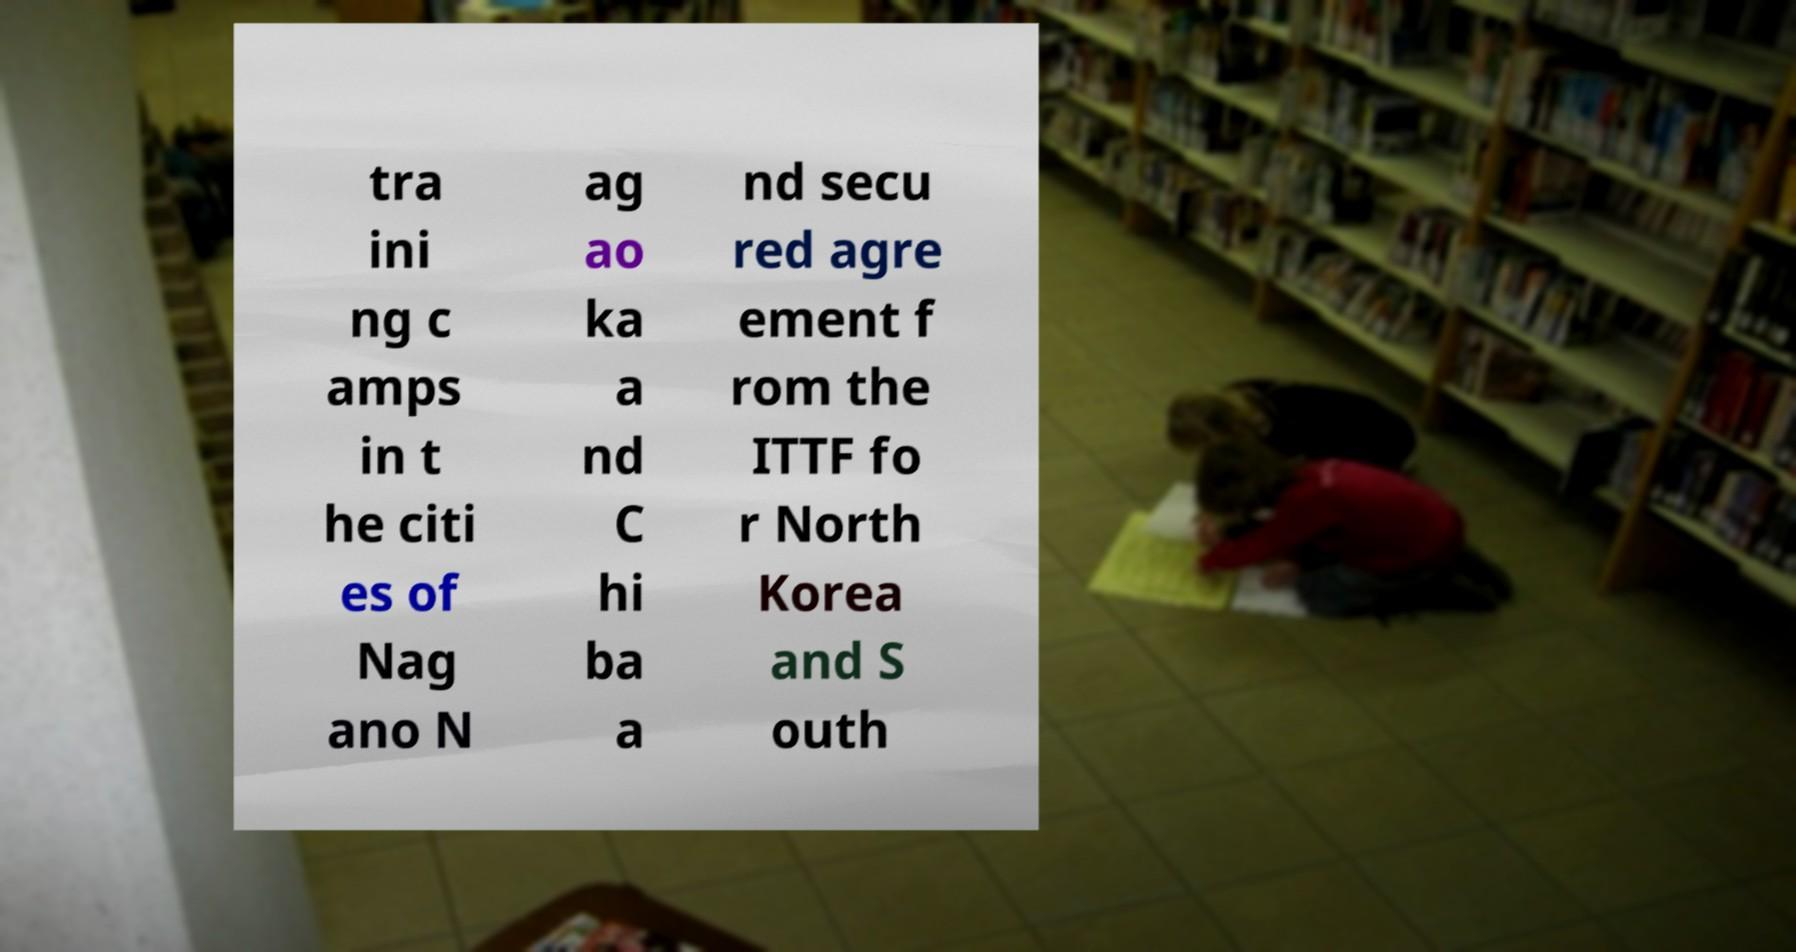Could you extract and type out the text from this image? tra ini ng c amps in t he citi es of Nag ano N ag ao ka a nd C hi ba a nd secu red agre ement f rom the ITTF fo r North Korea and S outh 